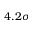<formula> <loc_0><loc_0><loc_500><loc_500>4 . 2 \sigma</formula> 